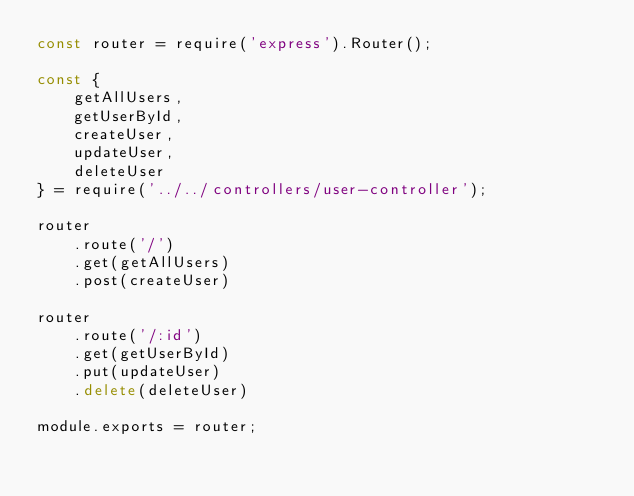Convert code to text. <code><loc_0><loc_0><loc_500><loc_500><_JavaScript_>const router = require('express').Router();

const {
    getAllUsers,
    getUserById,
    createUser,
    updateUser,
    deleteUser
} = require('../../controllers/user-controller');

router
    .route('/')
    .get(getAllUsers)
    .post(createUser)

router
    .route('/:id')
    .get(getUserById)
    .put(updateUser)
    .delete(deleteUser)

module.exports = router;

</code> 